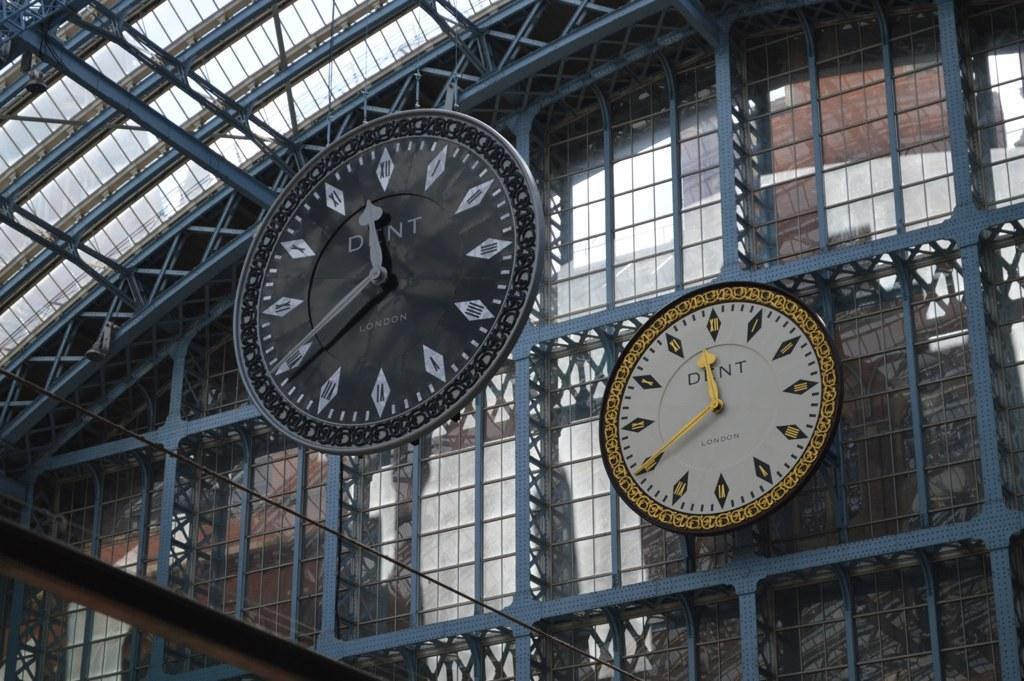How would you summarize this image in a sentence or two? This picture shows a building and we see a metal fence and we see couple of clocks. 